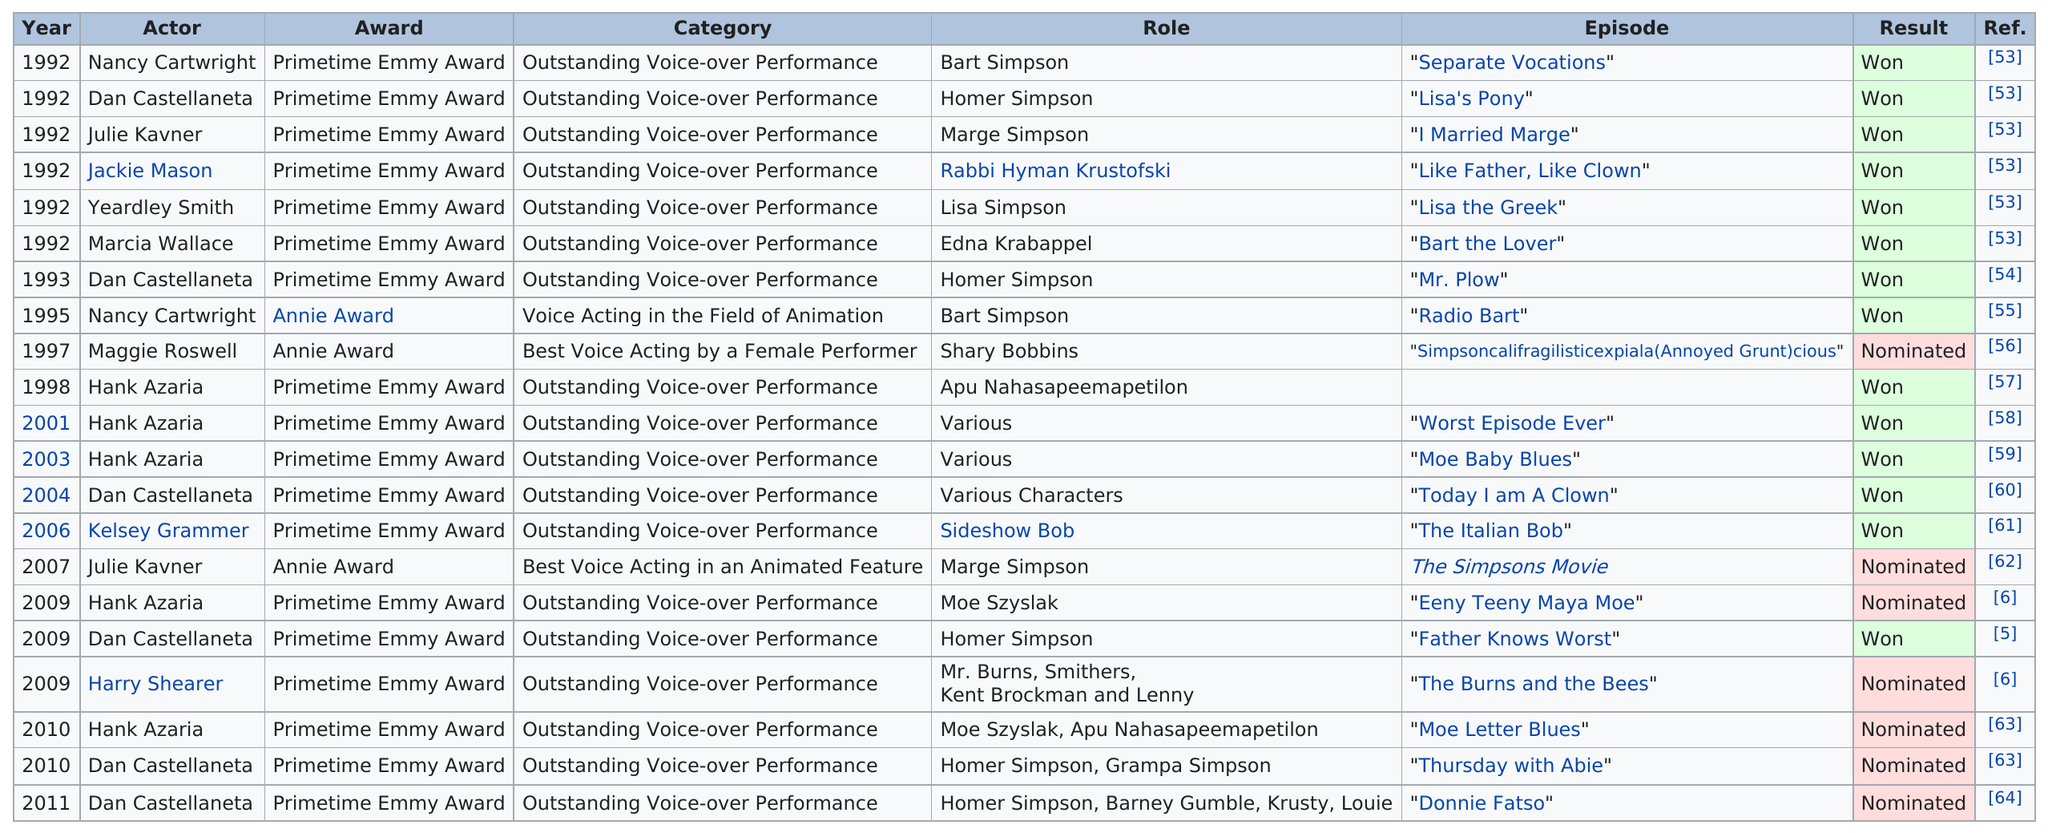Give some essential details in this illustration. In 2010, actors Dan Castellaneta and Hank Azaria received Primetime Emmy Awards for their outstanding voice-over performances on the Simpsons cartoon television show. In the previous decade, they both received the same type of Primetime Emmy Award for their work on the show during the same year: 2009. In the 1990s, the number of nominations was 10. A total of 7 nominations did not result in a win. In 1992, the most nominations were received. Nancy Cartwright won a Primetime Emmy Award in 1992 for her voice performance as Bart Simpson in the episode "Separate Vocations." However, she later received an Annie Award in 1995 for her portrayal of Bart Simpson in the "Radio Bart" episode, which marked her first Emmy and Annie Award win for the same character. 